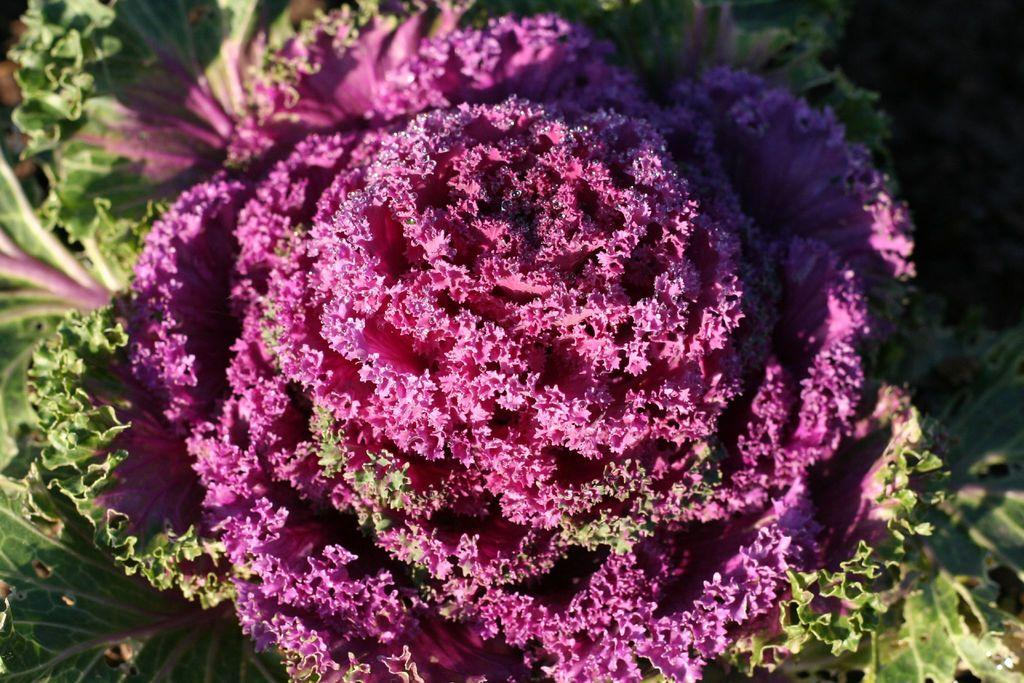What type of vegetable is present in the image? There is a cabbage in the image. Can you describe the appearance of the cabbage? The cabbage appears to be green and round in shape. Is the cabbage the only object in the image? The provided facts do not mention any other objects in the image, so we can only confirm the presence of the cabbage. Who is the owner of the cabbage in the image? There is no information provided about the ownership of the cabbage in the image. 